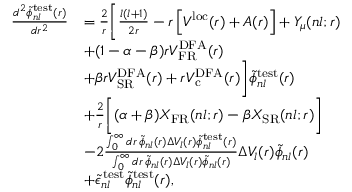Convert formula to latex. <formula><loc_0><loc_0><loc_500><loc_500>\begin{array} { r l } { \frac { d ^ { 2 } \widetilde { \phi } _ { n l } ^ { t e s t } ( r ) } { d r ^ { 2 } } } & { = \frac { 2 } { r } \left [ \frac { l ( l + 1 ) } { 2 r } - r \left [ V ^ { l o c } ( r ) + A ( r ) \right ] + Y _ { \mu } ( n l ; r ) } \\ & { + ( 1 - \alpha - \beta ) r V _ { F R } ^ { D F A } ( r ) } \\ & { + \beta r V _ { S R } ^ { D F A } ( r ) + r V _ { c } ^ { D F A } ( r ) \right ] \widetilde { \phi } _ { n l } ^ { t e s t } ( r ) } \\ & { + \frac { 2 } { r } \left [ ( \alpha + \beta ) X _ { F R } ( n l ; r ) - \beta X _ { S R } ( n l ; r ) \right ] } \\ & { - 2 \frac { \int _ { 0 } ^ { \infty } d r \, \widetilde { \phi } _ { n l } ( r ) \Delta V _ { l } ( r ) \widetilde { \phi } _ { n l } ^ { t e s t } ( r ) } { \int _ { 0 } ^ { \infty } d r \, \widetilde { \phi } _ { n l } ( r ) \Delta V _ { l } ( r ) \widetilde { \phi } _ { n l } ( r ) } \Delta V _ { l } ( r ) \widetilde { \phi } _ { n l } ( r ) } \\ & { + \widetilde { \epsilon } _ { n l } ^ { \, t e s t } \widetilde { \phi } _ { n l } ^ { t e s t } ( r ) , } \end{array}</formula> 